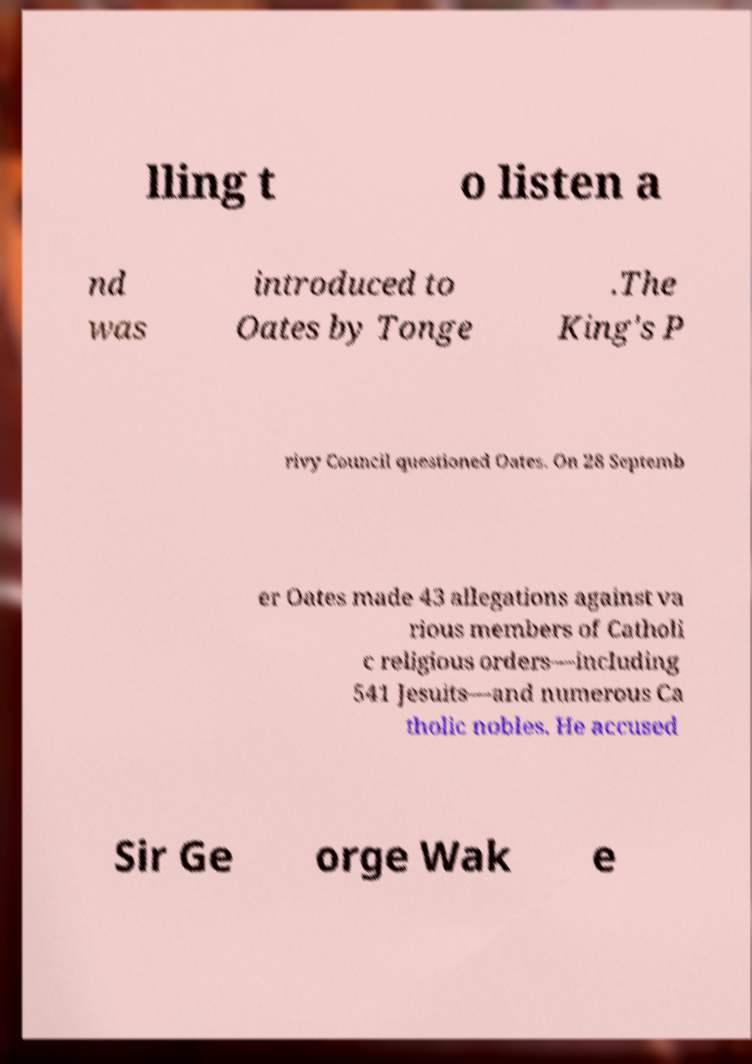There's text embedded in this image that I need extracted. Can you transcribe it verbatim? lling t o listen a nd was introduced to Oates by Tonge .The King's P rivy Council questioned Oates. On 28 Septemb er Oates made 43 allegations against va rious members of Catholi c religious orders—including 541 Jesuits—and numerous Ca tholic nobles. He accused Sir Ge orge Wak e 